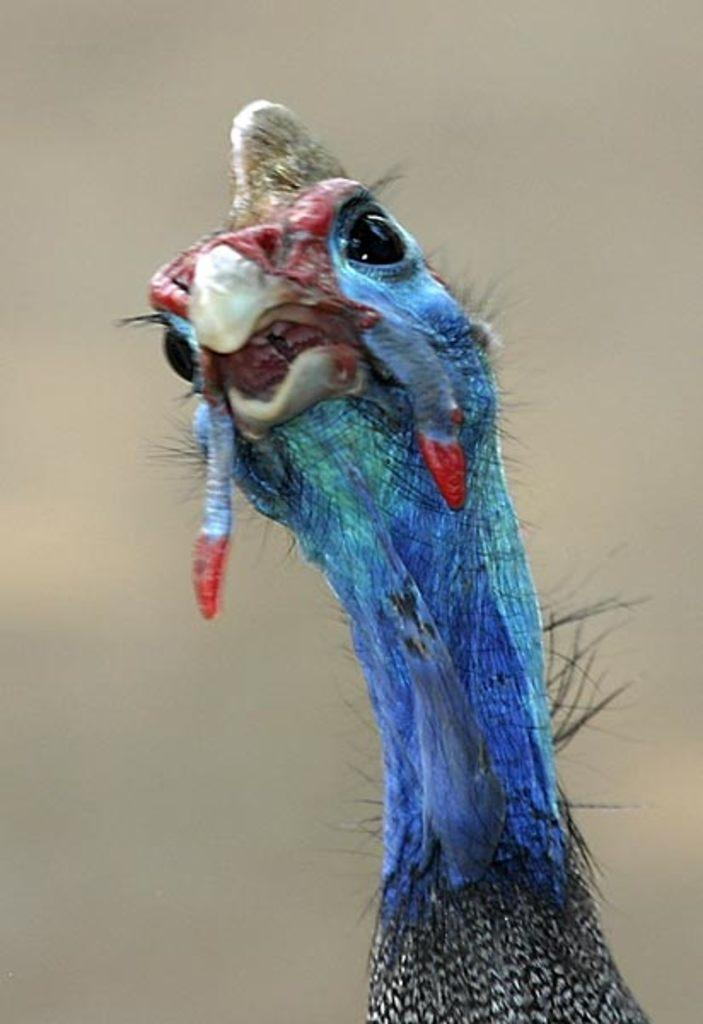What type of animal is in the picture? There is a bird in the picture. What colors are present on the bird's neck? The bird's neck has blue and black colors. How would you describe the background of the bird in the image? The background of the bird is blurry. What type of bone is visible in the bird's beak in the image? There is no bone visible in the bird's beak in the image. What belief system does the bird in the image follow? The image does not provide any information about the bird's belief system. 